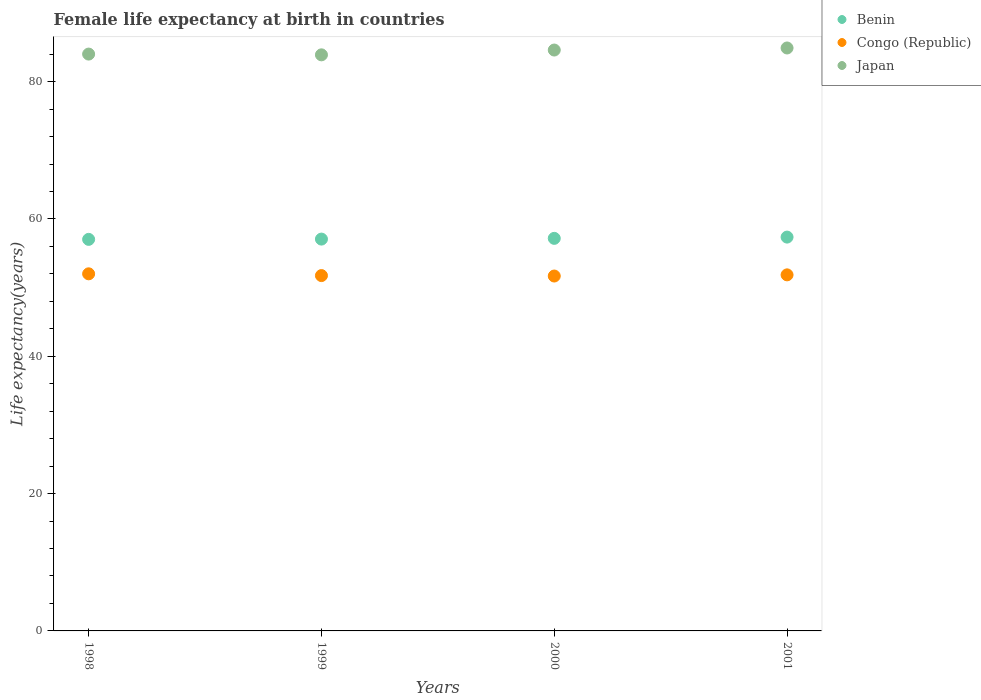How many different coloured dotlines are there?
Give a very brief answer. 3. Is the number of dotlines equal to the number of legend labels?
Your answer should be compact. Yes. What is the female life expectancy at birth in Benin in 2000?
Keep it short and to the point. 57.17. Across all years, what is the maximum female life expectancy at birth in Congo (Republic)?
Give a very brief answer. 52.01. Across all years, what is the minimum female life expectancy at birth in Congo (Republic)?
Your answer should be compact. 51.69. In which year was the female life expectancy at birth in Japan maximum?
Keep it short and to the point. 2001. In which year was the female life expectancy at birth in Japan minimum?
Give a very brief answer. 1999. What is the total female life expectancy at birth in Congo (Republic) in the graph?
Your answer should be compact. 207.3. What is the difference between the female life expectancy at birth in Congo (Republic) in 1999 and that in 2000?
Offer a very short reply. 0.06. What is the difference between the female life expectancy at birth in Japan in 1998 and the female life expectancy at birth in Congo (Republic) in 1999?
Provide a short and direct response. 32.26. What is the average female life expectancy at birth in Benin per year?
Your response must be concise. 57.16. In the year 1999, what is the difference between the female life expectancy at birth in Benin and female life expectancy at birth in Congo (Republic)?
Ensure brevity in your answer.  5.31. What is the ratio of the female life expectancy at birth in Japan in 1998 to that in 2000?
Offer a very short reply. 0.99. Is the difference between the female life expectancy at birth in Benin in 1999 and 2001 greater than the difference between the female life expectancy at birth in Congo (Republic) in 1999 and 2001?
Your answer should be very brief. No. What is the difference between the highest and the second highest female life expectancy at birth in Benin?
Your answer should be very brief. 0.18. What is the difference between the highest and the lowest female life expectancy at birth in Congo (Republic)?
Make the answer very short. 0.32. Is the sum of the female life expectancy at birth in Japan in 1999 and 2001 greater than the maximum female life expectancy at birth in Congo (Republic) across all years?
Your answer should be compact. Yes. Does the female life expectancy at birth in Congo (Republic) monotonically increase over the years?
Give a very brief answer. No. Is the female life expectancy at birth in Japan strictly greater than the female life expectancy at birth in Congo (Republic) over the years?
Your answer should be compact. Yes. What is the difference between two consecutive major ticks on the Y-axis?
Offer a terse response. 20. Where does the legend appear in the graph?
Give a very brief answer. Top right. How many legend labels are there?
Ensure brevity in your answer.  3. How are the legend labels stacked?
Provide a short and direct response. Vertical. What is the title of the graph?
Your answer should be compact. Female life expectancy at birth in countries. What is the label or title of the X-axis?
Offer a terse response. Years. What is the label or title of the Y-axis?
Your response must be concise. Life expectancy(years). What is the Life expectancy(years) of Benin in 1998?
Keep it short and to the point. 57.03. What is the Life expectancy(years) in Congo (Republic) in 1998?
Offer a very short reply. 52.01. What is the Life expectancy(years) in Japan in 1998?
Ensure brevity in your answer.  84.01. What is the Life expectancy(years) in Benin in 1999?
Your response must be concise. 57.07. What is the Life expectancy(years) of Congo (Republic) in 1999?
Your answer should be compact. 51.75. What is the Life expectancy(years) in Japan in 1999?
Your answer should be very brief. 83.9. What is the Life expectancy(years) of Benin in 2000?
Offer a very short reply. 57.17. What is the Life expectancy(years) of Congo (Republic) in 2000?
Keep it short and to the point. 51.69. What is the Life expectancy(years) of Japan in 2000?
Provide a succinct answer. 84.6. What is the Life expectancy(years) in Benin in 2001?
Your answer should be compact. 57.36. What is the Life expectancy(years) in Congo (Republic) in 2001?
Make the answer very short. 51.86. What is the Life expectancy(years) of Japan in 2001?
Offer a terse response. 84.9. Across all years, what is the maximum Life expectancy(years) in Benin?
Provide a succinct answer. 57.36. Across all years, what is the maximum Life expectancy(years) in Congo (Republic)?
Provide a succinct answer. 52.01. Across all years, what is the maximum Life expectancy(years) in Japan?
Your answer should be very brief. 84.9. Across all years, what is the minimum Life expectancy(years) in Benin?
Provide a succinct answer. 57.03. Across all years, what is the minimum Life expectancy(years) in Congo (Republic)?
Offer a very short reply. 51.69. Across all years, what is the minimum Life expectancy(years) of Japan?
Offer a terse response. 83.9. What is the total Life expectancy(years) in Benin in the graph?
Ensure brevity in your answer.  228.62. What is the total Life expectancy(years) in Congo (Republic) in the graph?
Make the answer very short. 207.3. What is the total Life expectancy(years) of Japan in the graph?
Offer a terse response. 337.41. What is the difference between the Life expectancy(years) in Benin in 1998 and that in 1999?
Your response must be concise. -0.04. What is the difference between the Life expectancy(years) of Congo (Republic) in 1998 and that in 1999?
Your answer should be compact. 0.26. What is the difference between the Life expectancy(years) in Japan in 1998 and that in 1999?
Keep it short and to the point. 0.11. What is the difference between the Life expectancy(years) of Benin in 1998 and that in 2000?
Your response must be concise. -0.15. What is the difference between the Life expectancy(years) of Congo (Republic) in 1998 and that in 2000?
Your answer should be very brief. 0.32. What is the difference between the Life expectancy(years) in Japan in 1998 and that in 2000?
Keep it short and to the point. -0.59. What is the difference between the Life expectancy(years) in Benin in 1998 and that in 2001?
Provide a succinct answer. -0.33. What is the difference between the Life expectancy(years) in Congo (Republic) in 1998 and that in 2001?
Provide a short and direct response. 0.15. What is the difference between the Life expectancy(years) in Japan in 1998 and that in 2001?
Your answer should be very brief. -0.89. What is the difference between the Life expectancy(years) in Benin in 1999 and that in 2000?
Keep it short and to the point. -0.11. What is the difference between the Life expectancy(years) in Congo (Republic) in 1999 and that in 2000?
Offer a very short reply. 0.06. What is the difference between the Life expectancy(years) of Benin in 1999 and that in 2001?
Your answer should be compact. -0.29. What is the difference between the Life expectancy(years) of Congo (Republic) in 1999 and that in 2001?
Your answer should be compact. -0.11. What is the difference between the Life expectancy(years) in Benin in 2000 and that in 2001?
Offer a very short reply. -0.18. What is the difference between the Life expectancy(years) in Congo (Republic) in 2000 and that in 2001?
Ensure brevity in your answer.  -0.17. What is the difference between the Life expectancy(years) in Japan in 2000 and that in 2001?
Offer a very short reply. -0.3. What is the difference between the Life expectancy(years) in Benin in 1998 and the Life expectancy(years) in Congo (Republic) in 1999?
Make the answer very short. 5.28. What is the difference between the Life expectancy(years) in Benin in 1998 and the Life expectancy(years) in Japan in 1999?
Give a very brief answer. -26.87. What is the difference between the Life expectancy(years) in Congo (Republic) in 1998 and the Life expectancy(years) in Japan in 1999?
Make the answer very short. -31.89. What is the difference between the Life expectancy(years) in Benin in 1998 and the Life expectancy(years) in Congo (Republic) in 2000?
Offer a terse response. 5.34. What is the difference between the Life expectancy(years) of Benin in 1998 and the Life expectancy(years) of Japan in 2000?
Provide a short and direct response. -27.57. What is the difference between the Life expectancy(years) in Congo (Republic) in 1998 and the Life expectancy(years) in Japan in 2000?
Your response must be concise. -32.59. What is the difference between the Life expectancy(years) in Benin in 1998 and the Life expectancy(years) in Congo (Republic) in 2001?
Your answer should be very brief. 5.17. What is the difference between the Life expectancy(years) in Benin in 1998 and the Life expectancy(years) in Japan in 2001?
Your answer should be very brief. -27.87. What is the difference between the Life expectancy(years) of Congo (Republic) in 1998 and the Life expectancy(years) of Japan in 2001?
Your response must be concise. -32.89. What is the difference between the Life expectancy(years) of Benin in 1999 and the Life expectancy(years) of Congo (Republic) in 2000?
Provide a succinct answer. 5.38. What is the difference between the Life expectancy(years) in Benin in 1999 and the Life expectancy(years) in Japan in 2000?
Offer a terse response. -27.53. What is the difference between the Life expectancy(years) in Congo (Republic) in 1999 and the Life expectancy(years) in Japan in 2000?
Ensure brevity in your answer.  -32.85. What is the difference between the Life expectancy(years) in Benin in 1999 and the Life expectancy(years) in Congo (Republic) in 2001?
Your answer should be very brief. 5.21. What is the difference between the Life expectancy(years) of Benin in 1999 and the Life expectancy(years) of Japan in 2001?
Your response must be concise. -27.83. What is the difference between the Life expectancy(years) in Congo (Republic) in 1999 and the Life expectancy(years) in Japan in 2001?
Make the answer very short. -33.15. What is the difference between the Life expectancy(years) in Benin in 2000 and the Life expectancy(years) in Congo (Republic) in 2001?
Your answer should be very brief. 5.32. What is the difference between the Life expectancy(years) in Benin in 2000 and the Life expectancy(years) in Japan in 2001?
Ensure brevity in your answer.  -27.73. What is the difference between the Life expectancy(years) in Congo (Republic) in 2000 and the Life expectancy(years) in Japan in 2001?
Keep it short and to the point. -33.21. What is the average Life expectancy(years) of Benin per year?
Give a very brief answer. 57.16. What is the average Life expectancy(years) in Congo (Republic) per year?
Offer a terse response. 51.83. What is the average Life expectancy(years) of Japan per year?
Provide a short and direct response. 84.35. In the year 1998, what is the difference between the Life expectancy(years) in Benin and Life expectancy(years) in Congo (Republic)?
Your answer should be very brief. 5.02. In the year 1998, what is the difference between the Life expectancy(years) in Benin and Life expectancy(years) in Japan?
Offer a terse response. -26.98. In the year 1998, what is the difference between the Life expectancy(years) in Congo (Republic) and Life expectancy(years) in Japan?
Provide a short and direct response. -32. In the year 1999, what is the difference between the Life expectancy(years) of Benin and Life expectancy(years) of Congo (Republic)?
Your answer should be compact. 5.32. In the year 1999, what is the difference between the Life expectancy(years) of Benin and Life expectancy(years) of Japan?
Offer a very short reply. -26.83. In the year 1999, what is the difference between the Life expectancy(years) in Congo (Republic) and Life expectancy(years) in Japan?
Keep it short and to the point. -32.15. In the year 2000, what is the difference between the Life expectancy(years) of Benin and Life expectancy(years) of Congo (Republic)?
Offer a terse response. 5.49. In the year 2000, what is the difference between the Life expectancy(years) of Benin and Life expectancy(years) of Japan?
Your response must be concise. -27.43. In the year 2000, what is the difference between the Life expectancy(years) in Congo (Republic) and Life expectancy(years) in Japan?
Provide a succinct answer. -32.91. In the year 2001, what is the difference between the Life expectancy(years) in Benin and Life expectancy(years) in Japan?
Offer a very short reply. -27.54. In the year 2001, what is the difference between the Life expectancy(years) in Congo (Republic) and Life expectancy(years) in Japan?
Keep it short and to the point. -33.04. What is the ratio of the Life expectancy(years) of Congo (Republic) in 1998 to that in 1999?
Provide a succinct answer. 1. What is the ratio of the Life expectancy(years) of Japan in 1998 to that in 1999?
Ensure brevity in your answer.  1. What is the ratio of the Life expectancy(years) of Benin in 1998 to that in 2001?
Ensure brevity in your answer.  0.99. What is the ratio of the Life expectancy(years) in Congo (Republic) in 1998 to that in 2001?
Your response must be concise. 1. What is the ratio of the Life expectancy(years) in Japan in 1998 to that in 2001?
Give a very brief answer. 0.99. What is the ratio of the Life expectancy(years) of Benin in 1999 to that in 2000?
Ensure brevity in your answer.  1. What is the ratio of the Life expectancy(years) in Congo (Republic) in 1999 to that in 2000?
Offer a terse response. 1. What is the ratio of the Life expectancy(years) in Benin in 1999 to that in 2001?
Provide a succinct answer. 0.99. What is the ratio of the Life expectancy(years) of Benin in 2000 to that in 2001?
Provide a succinct answer. 1. What is the difference between the highest and the second highest Life expectancy(years) of Benin?
Your response must be concise. 0.18. What is the difference between the highest and the second highest Life expectancy(years) of Congo (Republic)?
Provide a short and direct response. 0.15. What is the difference between the highest and the lowest Life expectancy(years) of Benin?
Keep it short and to the point. 0.33. What is the difference between the highest and the lowest Life expectancy(years) in Congo (Republic)?
Make the answer very short. 0.32. What is the difference between the highest and the lowest Life expectancy(years) of Japan?
Make the answer very short. 1. 